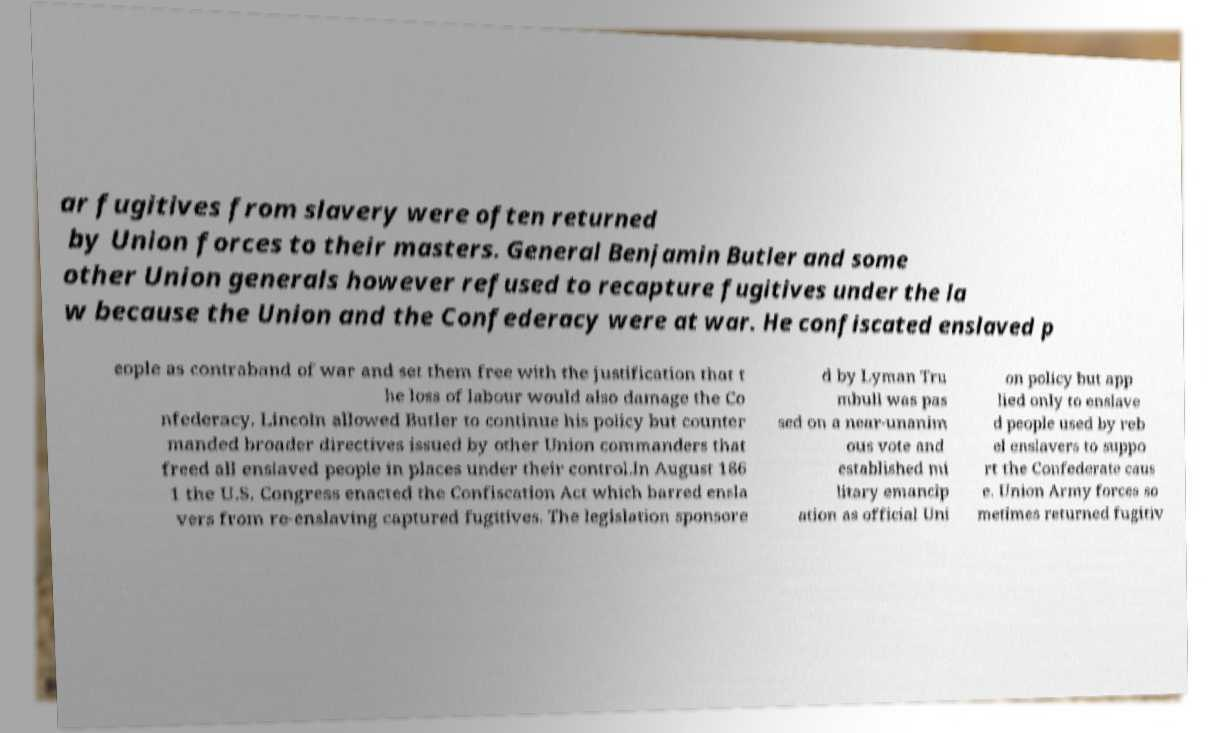Please read and relay the text visible in this image. What does it say? ar fugitives from slavery were often returned by Union forces to their masters. General Benjamin Butler and some other Union generals however refused to recapture fugitives under the la w because the Union and the Confederacy were at war. He confiscated enslaved p eople as contraband of war and set them free with the justification that t he loss of labour would also damage the Co nfederacy. Lincoln allowed Butler to continue his policy but counter manded broader directives issued by other Union commanders that freed all enslaved people in places under their control.In August 186 1 the U.S. Congress enacted the Confiscation Act which barred ensla vers from re-enslaving captured fugitives. The legislation sponsore d by Lyman Tru mbull was pas sed on a near-unanim ous vote and established mi litary emancip ation as official Uni on policy but app lied only to enslave d people used by reb el enslavers to suppo rt the Confederate caus e. Union Army forces so metimes returned fugitiv 